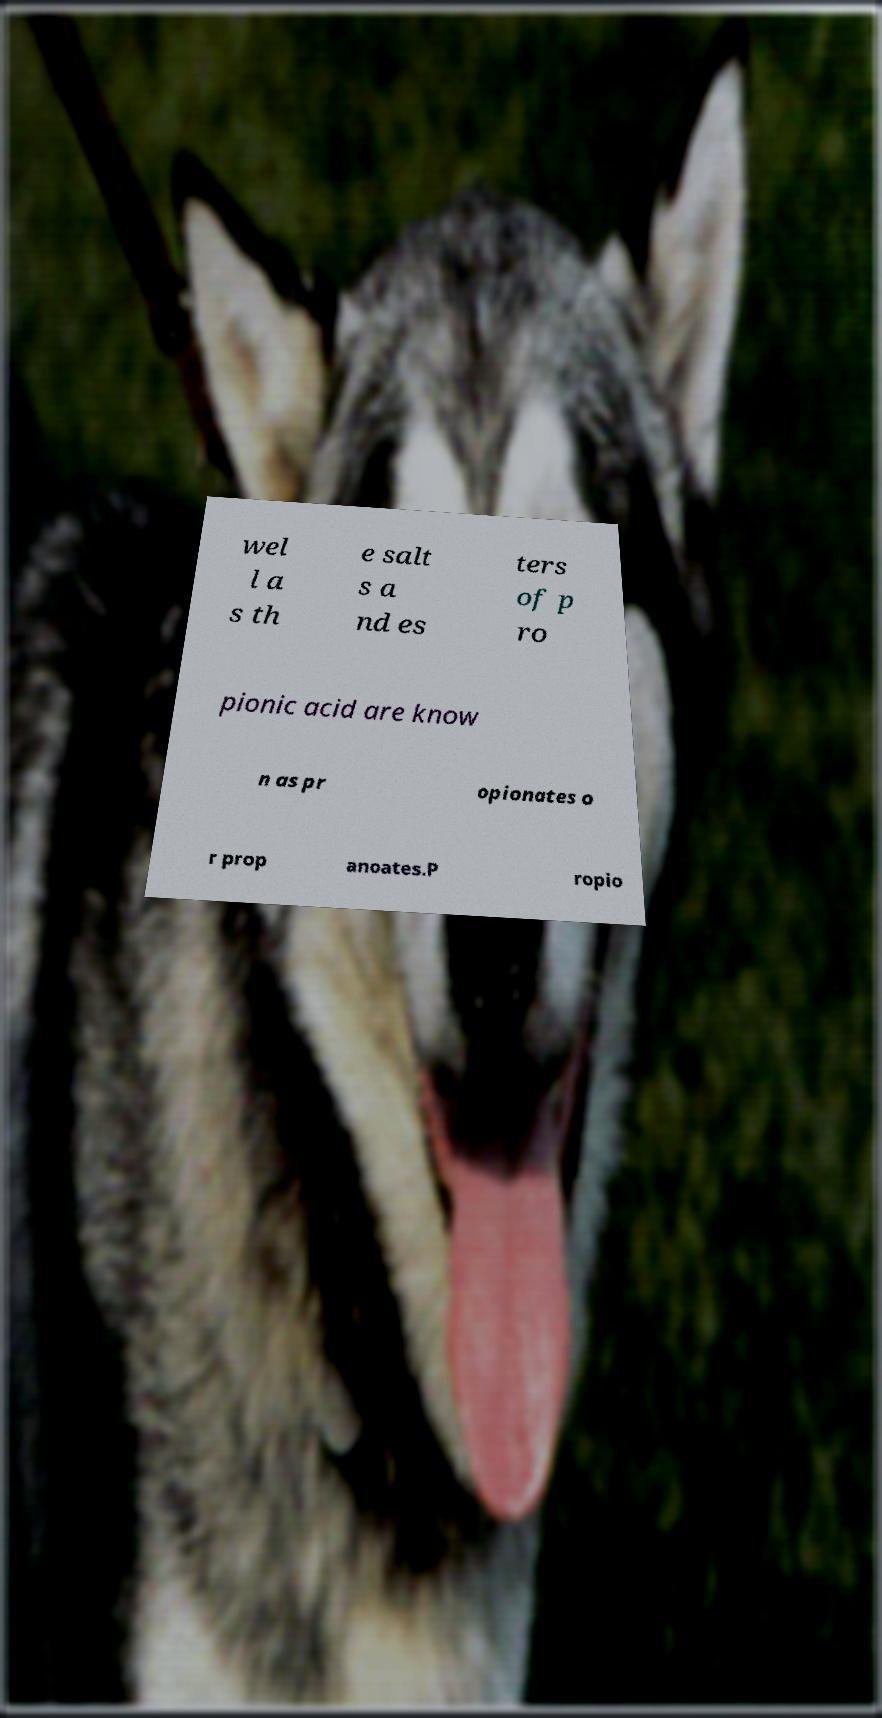Could you assist in decoding the text presented in this image and type it out clearly? wel l a s th e salt s a nd es ters of p ro pionic acid are know n as pr opionates o r prop anoates.P ropio 